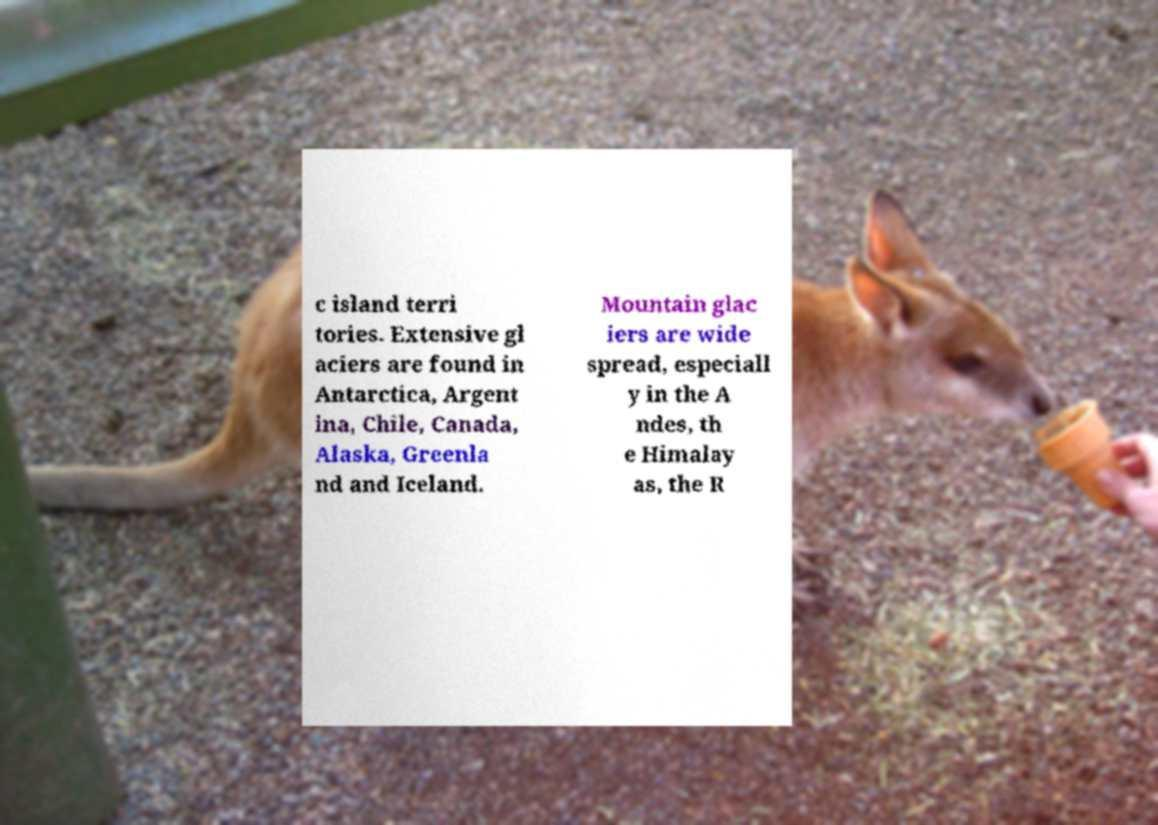Please read and relay the text visible in this image. What does it say? c island terri tories. Extensive gl aciers are found in Antarctica, Argent ina, Chile, Canada, Alaska, Greenla nd and Iceland. Mountain glac iers are wide spread, especiall y in the A ndes, th e Himalay as, the R 